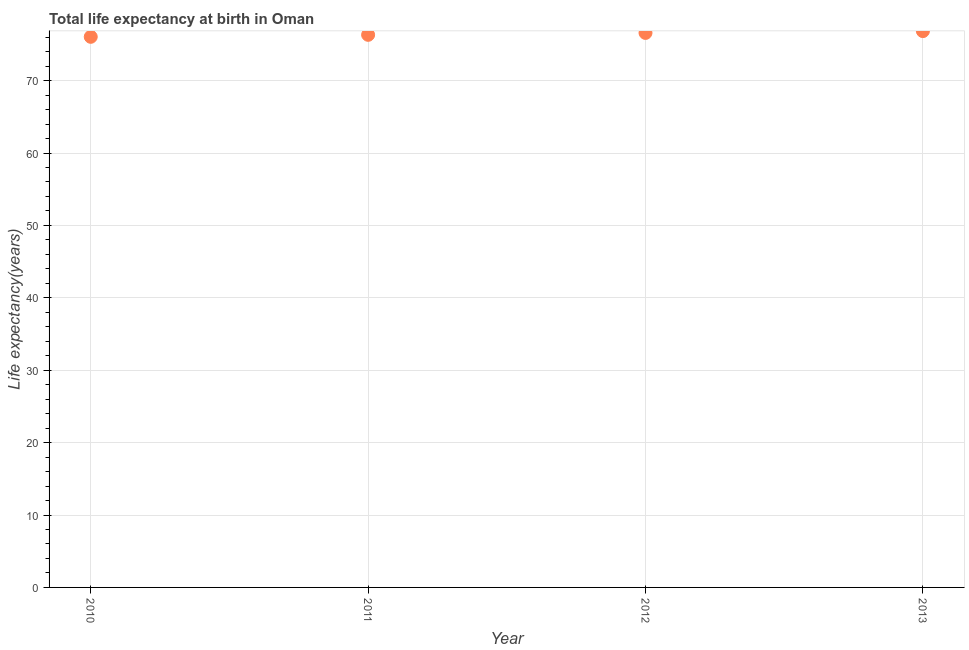What is the life expectancy at birth in 2013?
Your response must be concise. 76.84. Across all years, what is the maximum life expectancy at birth?
Your response must be concise. 76.84. Across all years, what is the minimum life expectancy at birth?
Your answer should be compact. 76.05. What is the sum of the life expectancy at birth?
Your answer should be compact. 305.81. What is the difference between the life expectancy at birth in 2010 and 2011?
Provide a short and direct response. -0.27. What is the average life expectancy at birth per year?
Your answer should be compact. 76.45. What is the median life expectancy at birth?
Make the answer very short. 76.46. In how many years, is the life expectancy at birth greater than 64 years?
Offer a terse response. 4. What is the ratio of the life expectancy at birth in 2010 to that in 2011?
Your response must be concise. 1. Is the life expectancy at birth in 2010 less than that in 2013?
Offer a very short reply. Yes. Is the difference between the life expectancy at birth in 2011 and 2013 greater than the difference between any two years?
Offer a terse response. No. What is the difference between the highest and the second highest life expectancy at birth?
Offer a very short reply. 0.25. Is the sum of the life expectancy at birth in 2010 and 2013 greater than the maximum life expectancy at birth across all years?
Give a very brief answer. Yes. What is the difference between the highest and the lowest life expectancy at birth?
Ensure brevity in your answer.  0.79. In how many years, is the life expectancy at birth greater than the average life expectancy at birth taken over all years?
Your answer should be compact. 2. How many years are there in the graph?
Provide a short and direct response. 4. Does the graph contain any zero values?
Offer a terse response. No. Does the graph contain grids?
Give a very brief answer. Yes. What is the title of the graph?
Your response must be concise. Total life expectancy at birth in Oman. What is the label or title of the X-axis?
Your response must be concise. Year. What is the label or title of the Y-axis?
Your answer should be compact. Life expectancy(years). What is the Life expectancy(years) in 2010?
Your answer should be compact. 76.05. What is the Life expectancy(years) in 2011?
Your answer should be very brief. 76.33. What is the Life expectancy(years) in 2012?
Keep it short and to the point. 76.59. What is the Life expectancy(years) in 2013?
Your answer should be compact. 76.84. What is the difference between the Life expectancy(years) in 2010 and 2011?
Ensure brevity in your answer.  -0.27. What is the difference between the Life expectancy(years) in 2010 and 2012?
Provide a short and direct response. -0.54. What is the difference between the Life expectancy(years) in 2010 and 2013?
Keep it short and to the point. -0.79. What is the difference between the Life expectancy(years) in 2011 and 2012?
Your answer should be very brief. -0.26. What is the difference between the Life expectancy(years) in 2011 and 2013?
Your answer should be very brief. -0.51. What is the difference between the Life expectancy(years) in 2012 and 2013?
Keep it short and to the point. -0.25. What is the ratio of the Life expectancy(years) in 2011 to that in 2012?
Keep it short and to the point. 1. What is the ratio of the Life expectancy(years) in 2011 to that in 2013?
Your response must be concise. 0.99. What is the ratio of the Life expectancy(years) in 2012 to that in 2013?
Make the answer very short. 1. 